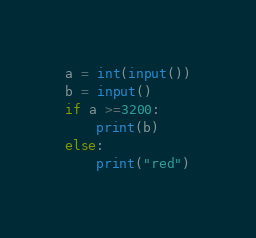<code> <loc_0><loc_0><loc_500><loc_500><_Python_>a = int(input())
b = input()
if a >=3200:
    print(b)
else:
    print("red")
</code> 